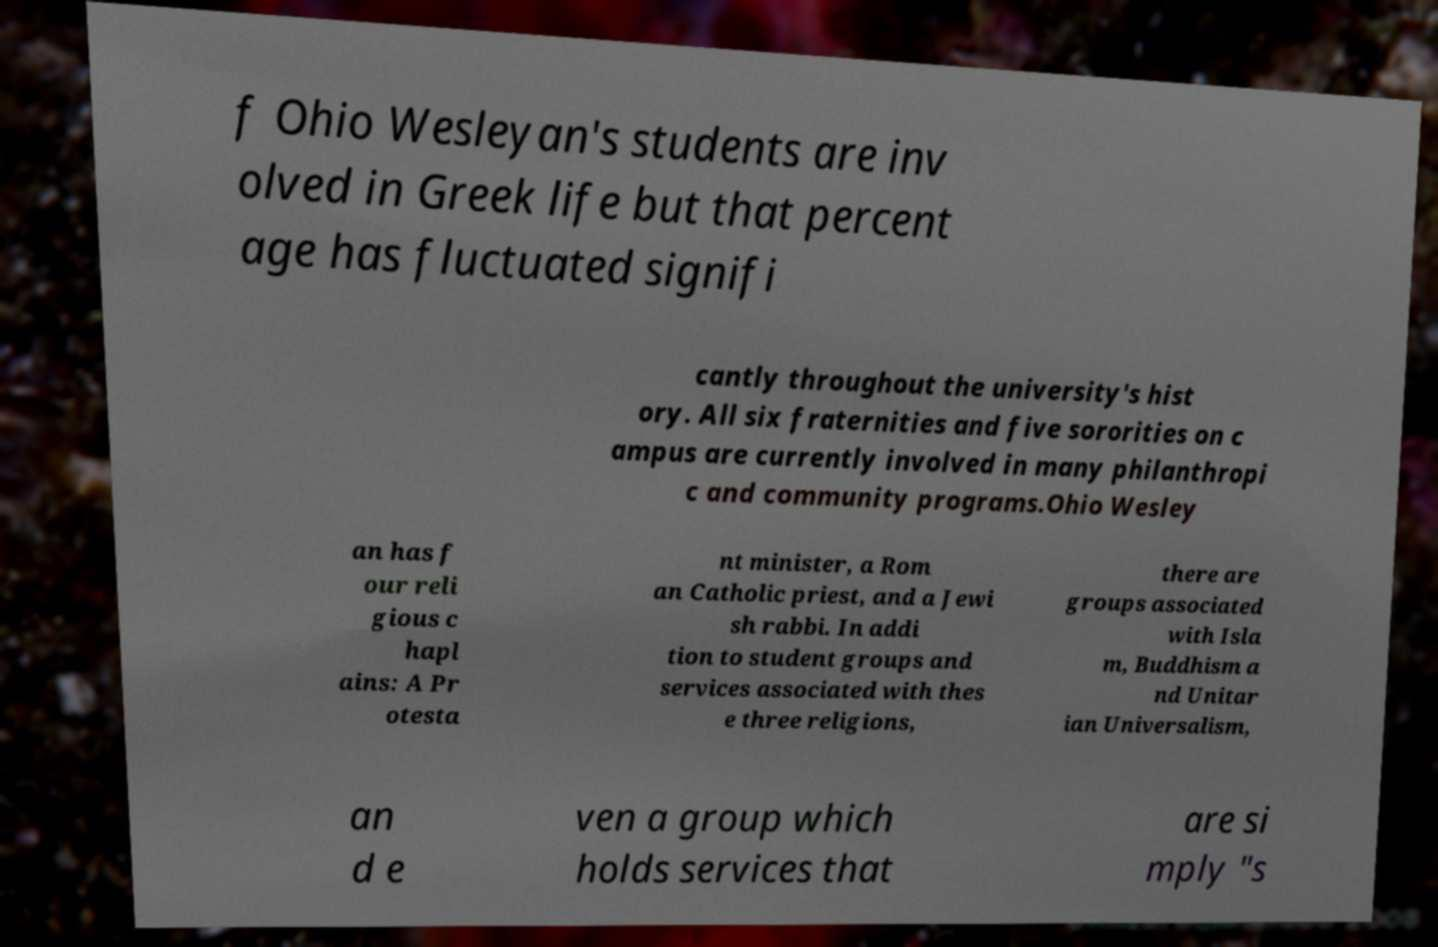Could you extract and type out the text from this image? f Ohio Wesleyan's students are inv olved in Greek life but that percent age has fluctuated signifi cantly throughout the university's hist ory. All six fraternities and five sororities on c ampus are currently involved in many philanthropi c and community programs.Ohio Wesley an has f our reli gious c hapl ains: A Pr otesta nt minister, a Rom an Catholic priest, and a Jewi sh rabbi. In addi tion to student groups and services associated with thes e three religions, there are groups associated with Isla m, Buddhism a nd Unitar ian Universalism, an d e ven a group which holds services that are si mply "s 